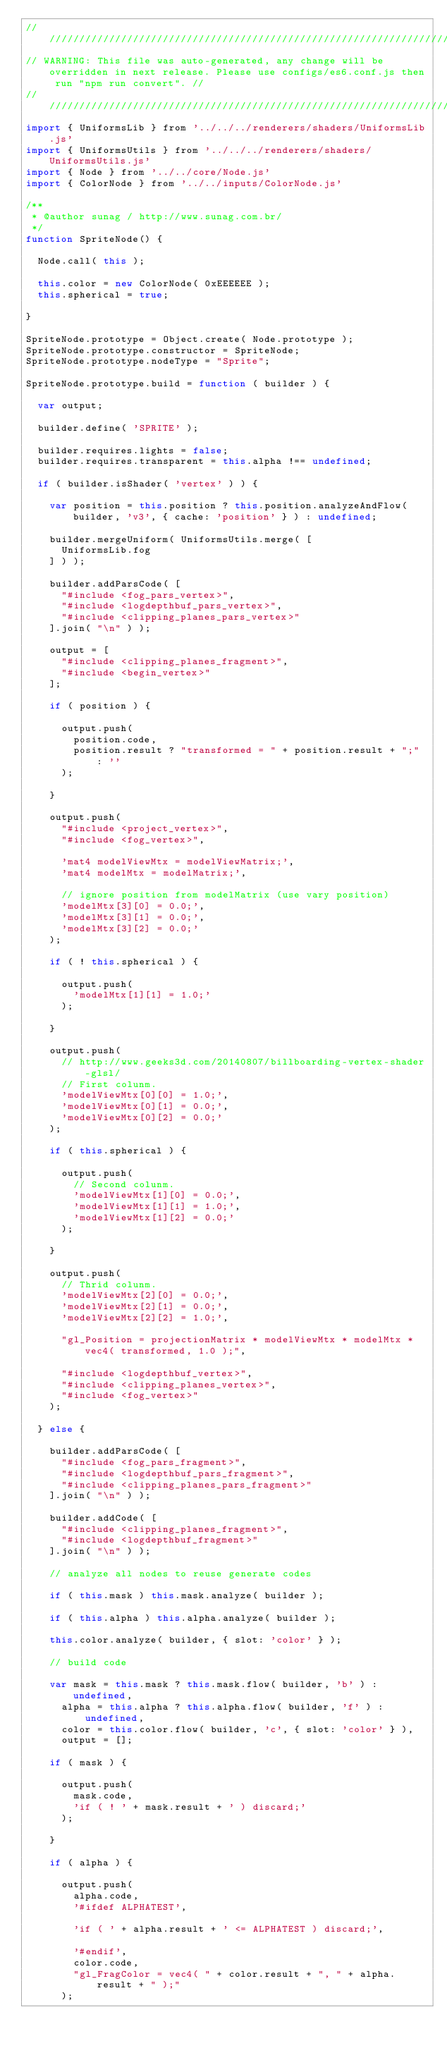Convert code to text. <code><loc_0><loc_0><loc_500><loc_500><_JavaScript_>//////////////////////////////////////////////////////////////////////////////////////////////////////////////////////////////////////////////////////
// WARNING: This file was auto-generated, any change will be overridden in next release. Please use configs/es6.conf.js then run "npm run convert". //
//////////////////////////////////////////////////////////////////////////////////////////////////////////////////////////////////////////////////////
import { UniformsLib } from '../../../renderers/shaders/UniformsLib.js'
import { UniformsUtils } from '../../../renderers/shaders/UniformsUtils.js'
import { Node } from '../../core/Node.js'
import { ColorNode } from '../../inputs/ColorNode.js'

/**
 * @author sunag / http://www.sunag.com.br/
 */
function SpriteNode() {

	Node.call( this );

	this.color = new ColorNode( 0xEEEEEE );
	this.spherical = true;

}

SpriteNode.prototype = Object.create( Node.prototype );
SpriteNode.prototype.constructor = SpriteNode;
SpriteNode.prototype.nodeType = "Sprite";

SpriteNode.prototype.build = function ( builder ) {

	var output;

	builder.define( 'SPRITE' );

	builder.requires.lights = false;
	builder.requires.transparent = this.alpha !== undefined;

	if ( builder.isShader( 'vertex' ) ) {

		var position = this.position ? this.position.analyzeAndFlow( builder, 'v3', { cache: 'position' } ) : undefined;

		builder.mergeUniform( UniformsUtils.merge( [
			UniformsLib.fog
		] ) );

		builder.addParsCode( [
			"#include <fog_pars_vertex>",
			"#include <logdepthbuf_pars_vertex>",
			"#include <clipping_planes_pars_vertex>"
		].join( "\n" ) );

		output = [
			"#include <clipping_planes_fragment>",
			"#include <begin_vertex>"
		];

		if ( position ) {

			output.push(
				position.code,
				position.result ? "transformed = " + position.result + ";" : ''
			);

		}

		output.push(
			"#include <project_vertex>",
			"#include <fog_vertex>",

			'mat4 modelViewMtx = modelViewMatrix;',
			'mat4 modelMtx = modelMatrix;',

			// ignore position from modelMatrix (use vary position)
			'modelMtx[3][0] = 0.0;',
			'modelMtx[3][1] = 0.0;',
			'modelMtx[3][2] = 0.0;'
		);

		if ( ! this.spherical ) {

			output.push(
				'modelMtx[1][1] = 1.0;'
			);

		}

		output.push(
			// http://www.geeks3d.com/20140807/billboarding-vertex-shader-glsl/
			// First colunm.
			'modelViewMtx[0][0] = 1.0;',
			'modelViewMtx[0][1] = 0.0;',
			'modelViewMtx[0][2] = 0.0;'
		);

		if ( this.spherical ) {

			output.push(
				// Second colunm.
				'modelViewMtx[1][0] = 0.0;',
				'modelViewMtx[1][1] = 1.0;',
				'modelViewMtx[1][2] = 0.0;'
			);

		}

		output.push(
			// Thrid colunm.
			'modelViewMtx[2][0] = 0.0;',
			'modelViewMtx[2][1] = 0.0;',
			'modelViewMtx[2][2] = 1.0;',

			"gl_Position = projectionMatrix * modelViewMtx * modelMtx * vec4( transformed, 1.0 );",

			"#include <logdepthbuf_vertex>",
			"#include <clipping_planes_vertex>",
			"#include <fog_vertex>"
		);

	} else {

		builder.addParsCode( [
			"#include <fog_pars_fragment>",
			"#include <logdepthbuf_pars_fragment>",
			"#include <clipping_planes_pars_fragment>"
		].join( "\n" ) );

		builder.addCode( [
			"#include <clipping_planes_fragment>",
			"#include <logdepthbuf_fragment>"
		].join( "\n" ) );

		// analyze all nodes to reuse generate codes

		if ( this.mask ) this.mask.analyze( builder );

		if ( this.alpha ) this.alpha.analyze( builder );

		this.color.analyze( builder, { slot: 'color' } );

		// build code

		var mask = this.mask ? this.mask.flow( builder, 'b' ) : undefined,
			alpha = this.alpha ? this.alpha.flow( builder, 'f' ) : undefined,
			color = this.color.flow( builder, 'c', { slot: 'color' } ),
			output = [];

		if ( mask ) {

			output.push(
				mask.code,
				'if ( ! ' + mask.result + ' ) discard;'
			);

		}

		if ( alpha ) {

			output.push(
				alpha.code,
				'#ifdef ALPHATEST',

				'if ( ' + alpha.result + ' <= ALPHATEST ) discard;',

				'#endif',
				color.code,
				"gl_FragColor = vec4( " + color.result + ", " + alpha.result + " );"
			);
</code> 